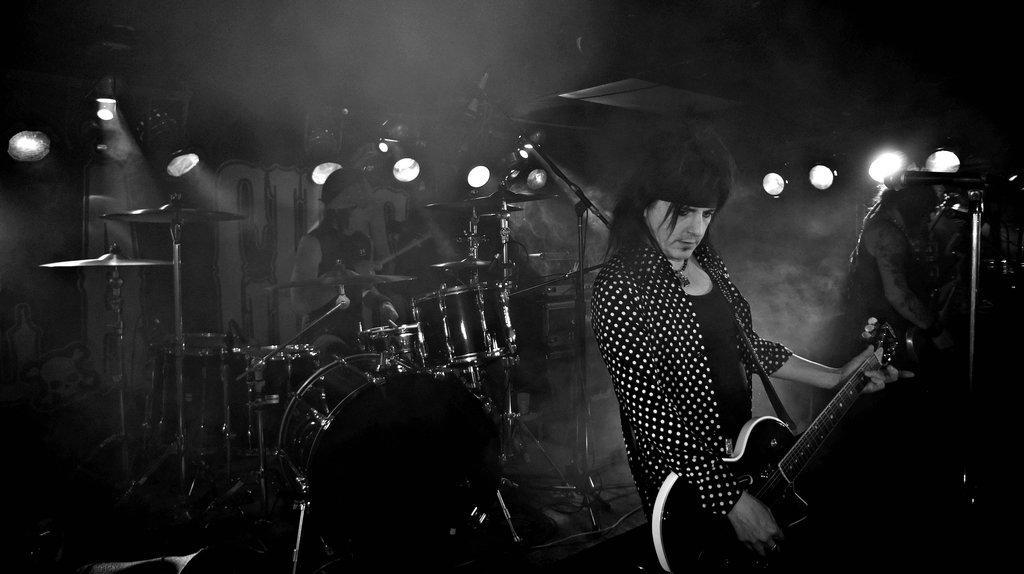In one or two sentences, can you explain what this image depicts? In this image I can see three persons are standing and on the right side of this image I can see two of them are holding guitars. In the background I can see a drum set, a mic, number of lights, smoke and I can also see one more mic on the right side of this image. I can also see this image is black and white in colour. 